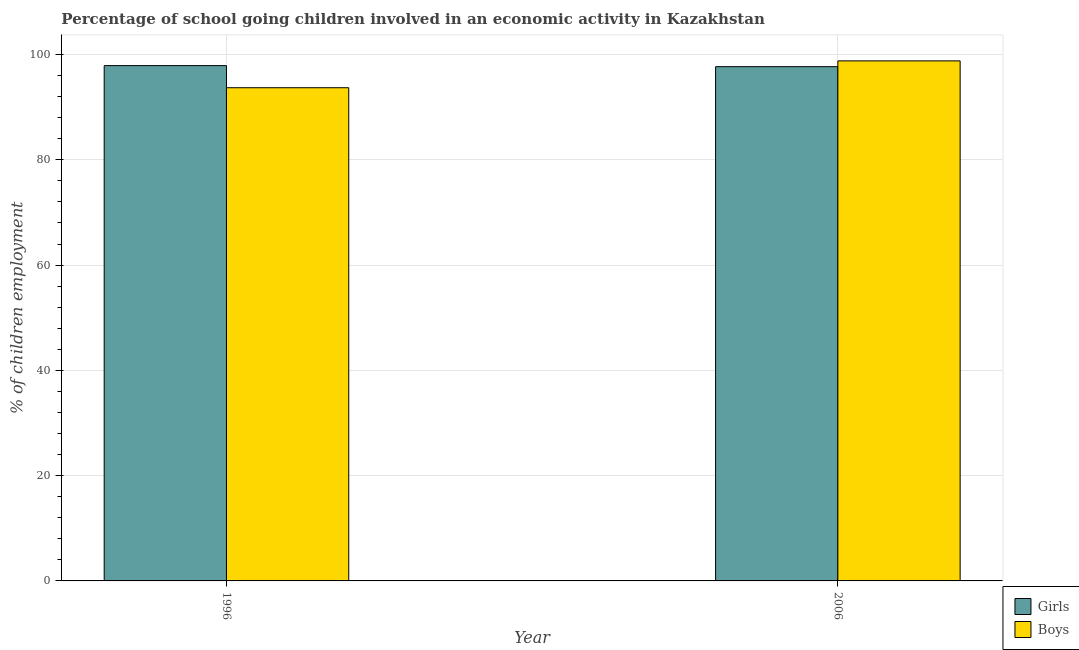How many groups of bars are there?
Your answer should be very brief. 2. Are the number of bars on each tick of the X-axis equal?
Your response must be concise. Yes. How many bars are there on the 2nd tick from the right?
Provide a short and direct response. 2. What is the label of the 1st group of bars from the left?
Make the answer very short. 1996. What is the percentage of school going girls in 1996?
Ensure brevity in your answer.  97.9. Across all years, what is the maximum percentage of school going girls?
Your answer should be compact. 97.9. Across all years, what is the minimum percentage of school going girls?
Your response must be concise. 97.7. In which year was the percentage of school going boys maximum?
Ensure brevity in your answer.  2006. What is the total percentage of school going boys in the graph?
Ensure brevity in your answer.  192.5. What is the difference between the percentage of school going girls in 1996 and that in 2006?
Your answer should be compact. 0.2. What is the difference between the percentage of school going boys in 2006 and the percentage of school going girls in 1996?
Offer a terse response. 5.1. What is the average percentage of school going boys per year?
Provide a short and direct response. 96.25. In the year 2006, what is the difference between the percentage of school going boys and percentage of school going girls?
Offer a very short reply. 0. In how many years, is the percentage of school going boys greater than 60 %?
Offer a very short reply. 2. What is the ratio of the percentage of school going boys in 1996 to that in 2006?
Your response must be concise. 0.95. What does the 2nd bar from the left in 1996 represents?
Offer a very short reply. Boys. What does the 2nd bar from the right in 2006 represents?
Offer a very short reply. Girls. Are all the bars in the graph horizontal?
Your response must be concise. No. What is the difference between two consecutive major ticks on the Y-axis?
Your response must be concise. 20. Does the graph contain any zero values?
Keep it short and to the point. No. Where does the legend appear in the graph?
Provide a short and direct response. Bottom right. What is the title of the graph?
Offer a very short reply. Percentage of school going children involved in an economic activity in Kazakhstan. What is the label or title of the Y-axis?
Make the answer very short. % of children employment. What is the % of children employment of Girls in 1996?
Ensure brevity in your answer.  97.9. What is the % of children employment in Boys in 1996?
Make the answer very short. 93.7. What is the % of children employment of Girls in 2006?
Offer a terse response. 97.7. What is the % of children employment of Boys in 2006?
Offer a terse response. 98.8. Across all years, what is the maximum % of children employment in Girls?
Offer a very short reply. 97.9. Across all years, what is the maximum % of children employment of Boys?
Keep it short and to the point. 98.8. Across all years, what is the minimum % of children employment in Girls?
Give a very brief answer. 97.7. Across all years, what is the minimum % of children employment in Boys?
Provide a succinct answer. 93.7. What is the total % of children employment of Girls in the graph?
Make the answer very short. 195.6. What is the total % of children employment of Boys in the graph?
Ensure brevity in your answer.  192.5. What is the average % of children employment of Girls per year?
Make the answer very short. 97.8. What is the average % of children employment in Boys per year?
Ensure brevity in your answer.  96.25. In the year 1996, what is the difference between the % of children employment in Girls and % of children employment in Boys?
Give a very brief answer. 4.2. In the year 2006, what is the difference between the % of children employment in Girls and % of children employment in Boys?
Give a very brief answer. -1.1. What is the ratio of the % of children employment in Girls in 1996 to that in 2006?
Your response must be concise. 1. What is the ratio of the % of children employment in Boys in 1996 to that in 2006?
Keep it short and to the point. 0.95. What is the difference between the highest and the second highest % of children employment of Girls?
Your answer should be compact. 0.2. What is the difference between the highest and the lowest % of children employment in Boys?
Offer a terse response. 5.1. 